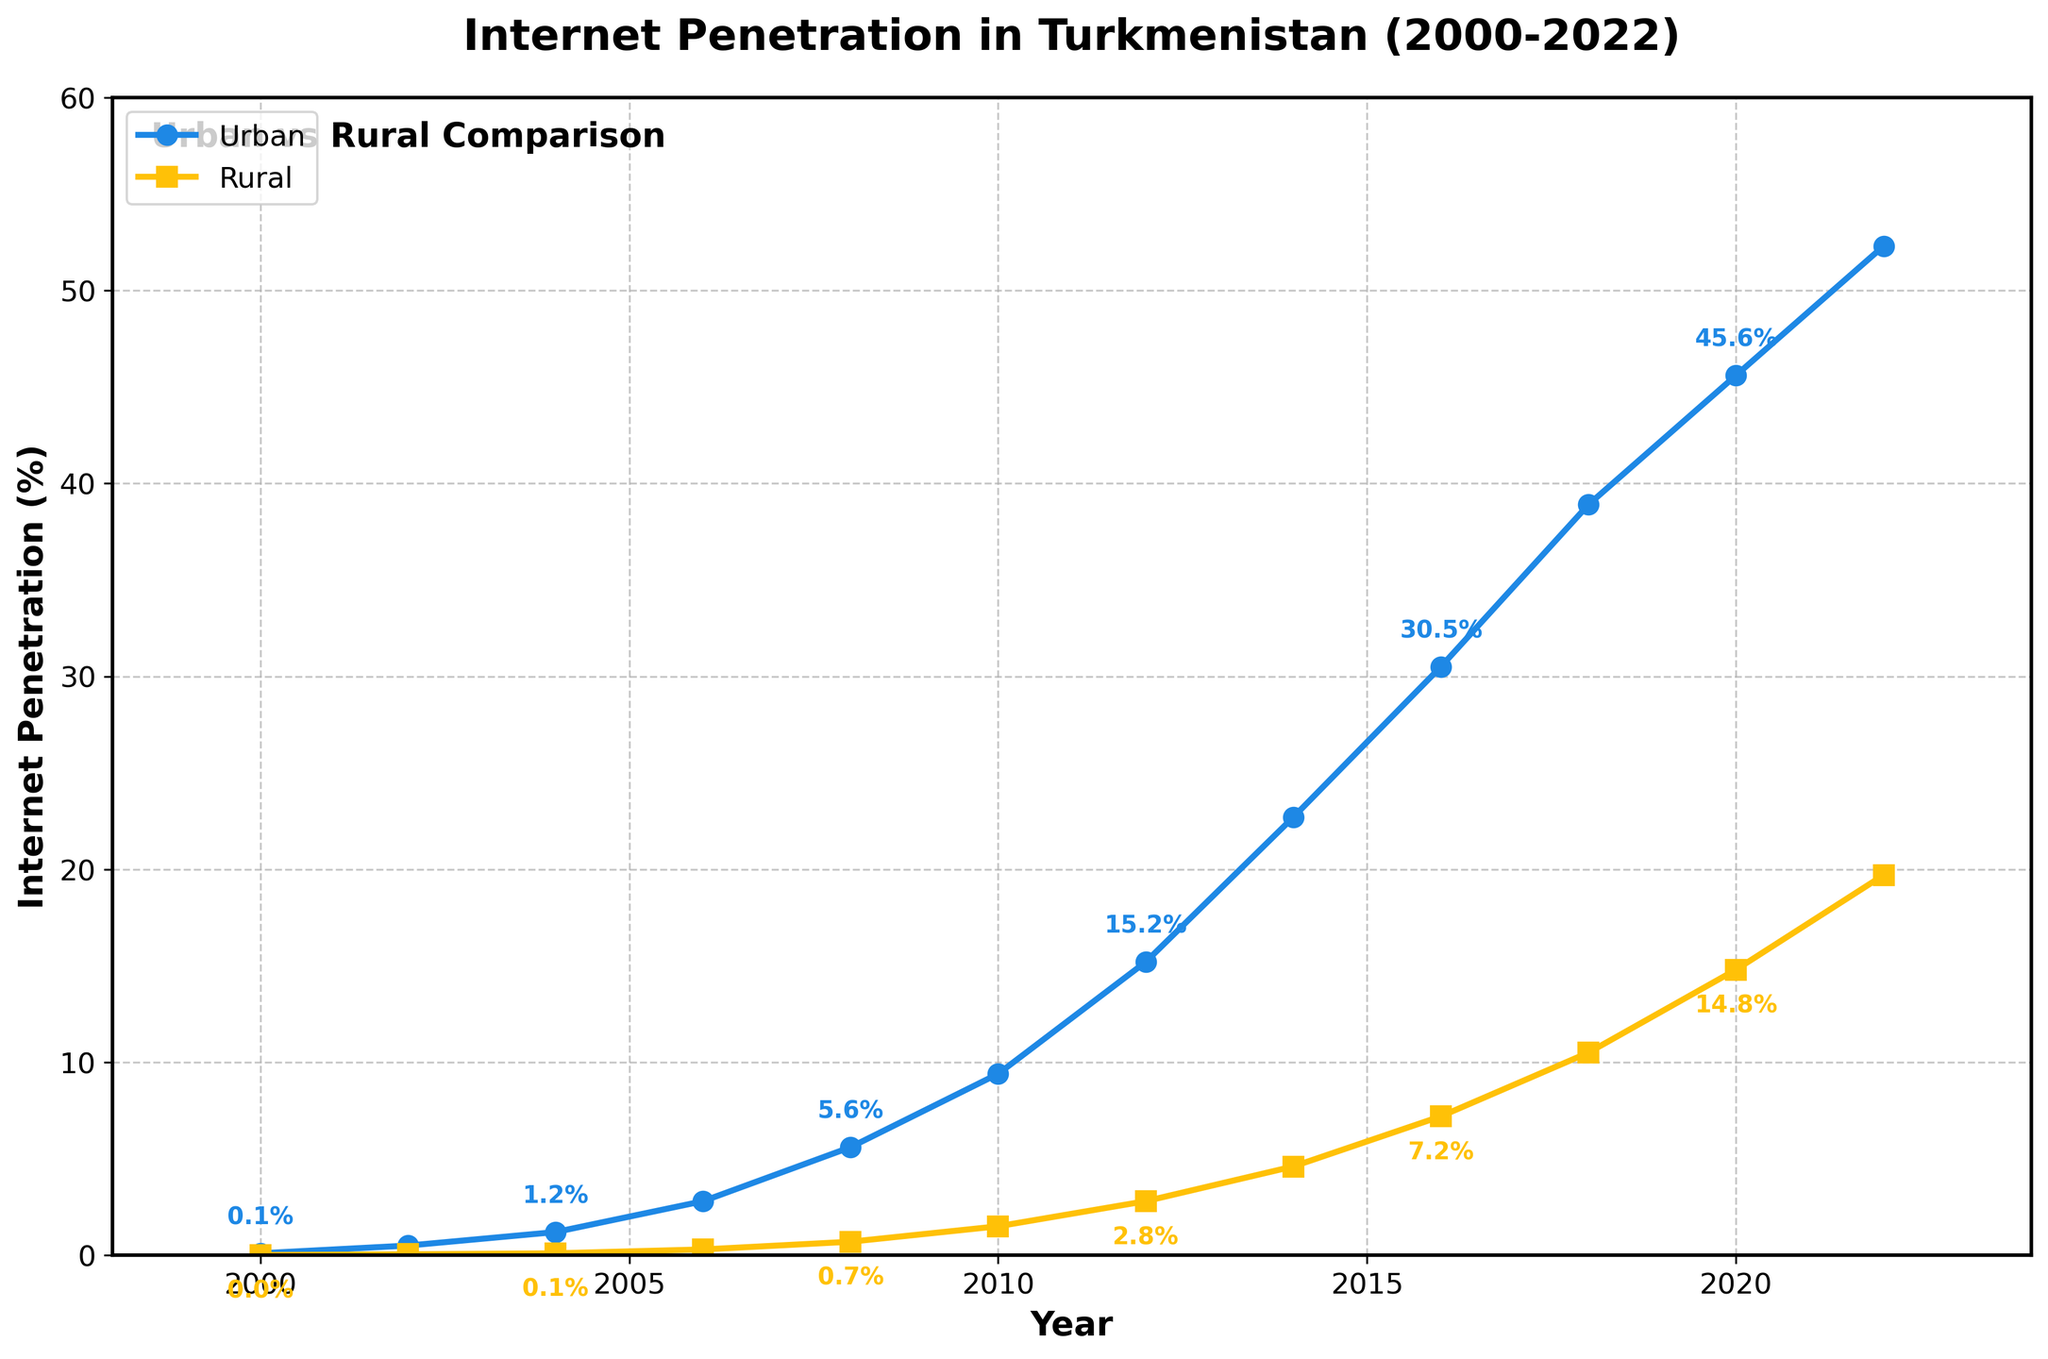What year did urban internet penetration surpass 10%? Based on the line chart, the urban internet penetration rate surpasses 10% between 2010 and 2012. By looking at the data point for 2012, it is 15.2%. Thus, it surpasses 10% in 2012.
Answer: 2012 Which area had a higher internet penetration rate in 2008, urban or rural? By comparing the internet penetration rates for 2008, the urban rate is 5.6% and the rural rate is 0.7%. Urban is higher than rural.
Answer: Urban When did the urban internet penetration rate first surpass 30%? Reviewing the chart data, the urban internet penetration rate surpasses 30% between 2014 and 2016. It reaches 30.5% by 2016. Thus, it surpasses 30% in 2016.
Answer: 2016 By how much did the urban internet penetration rate increase between 2006 and 2010? To calculate the increase, subtract the 2006 rate (2.8%) from the 2010 rate (9.4%). Therefore, 9.4% - 2.8% = 6.6%.
Answer: 6.6% What is the approximate difference in internet penetration rates between urban and rural areas in 2022? Find the internet penetration rates for both urban (52.3%) and rural (19.7%) in 2022. Subtract the rural rate from the urban rate: 52.3% - 19.7% = 32.6%.
Answer: 32.6% From which year did rural internet penetration start showing a noticeable increase? Observing the line for rural internet penetration, it starts from nearly flat and shows a noticeable increase from 2006 onwards where the rate goes above 0.3%.
Answer: 2006 What is the average urban internet penetration rate for the years 2000, 2010, and 2020? Add the urban internet penetration rates for these years (0.1%, 9.4%, 45.6%) and divide by 3: (0.1 + 9.4 + 45.6) / 3 = 55.1 / 3 = 18.37%.
Answer: 18.37% Which year witnessed the smallest gap between urban and rural internet penetration rates? Compare the gaps across all years; we see that in 2000, the urban rate is 0.1% and the rural is 0.01%, resulting in a gap of 0.09%, which is the smallest across all years observed.
Answer: 2000 By how much did the rural internet penetration rate grow from 2008 to 2022? Subtract the 2008 rural rate (0.7%) from the 2022 rate (19.7%). Thus, 19.7% - 0.7% = 19.0%.
Answer: 19.0% What color represents urban internet penetration on the chart? Refer to the visual attributes of the line chart, the urban internet penetration is represented by a blue line.
Answer: Blue 